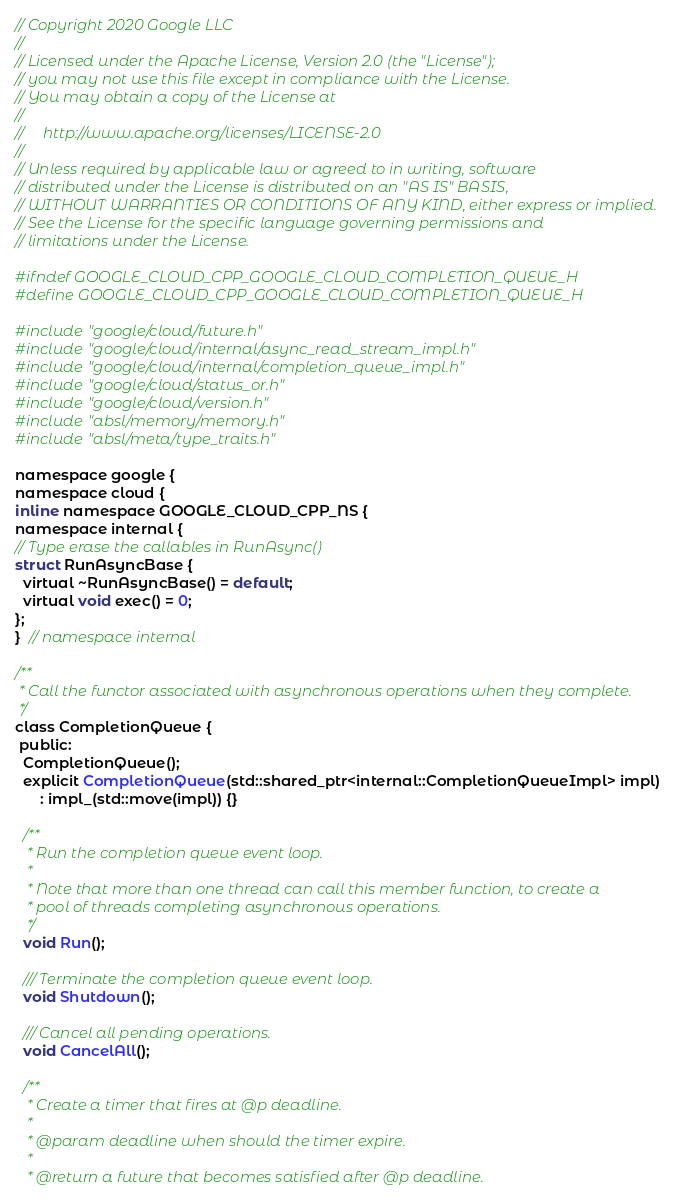Convert code to text. <code><loc_0><loc_0><loc_500><loc_500><_C_>// Copyright 2020 Google LLC
//
// Licensed under the Apache License, Version 2.0 (the "License");
// you may not use this file except in compliance with the License.
// You may obtain a copy of the License at
//
//     http://www.apache.org/licenses/LICENSE-2.0
//
// Unless required by applicable law or agreed to in writing, software
// distributed under the License is distributed on an "AS IS" BASIS,
// WITHOUT WARRANTIES OR CONDITIONS OF ANY KIND, either express or implied.
// See the License for the specific language governing permissions and
// limitations under the License.

#ifndef GOOGLE_CLOUD_CPP_GOOGLE_CLOUD_COMPLETION_QUEUE_H
#define GOOGLE_CLOUD_CPP_GOOGLE_CLOUD_COMPLETION_QUEUE_H

#include "google/cloud/future.h"
#include "google/cloud/internal/async_read_stream_impl.h"
#include "google/cloud/internal/completion_queue_impl.h"
#include "google/cloud/status_or.h"
#include "google/cloud/version.h"
#include "absl/memory/memory.h"
#include "absl/meta/type_traits.h"

namespace google {
namespace cloud {
inline namespace GOOGLE_CLOUD_CPP_NS {
namespace internal {
// Type erase the callables in RunAsync()
struct RunAsyncBase {
  virtual ~RunAsyncBase() = default;
  virtual void exec() = 0;
};
}  // namespace internal

/**
 * Call the functor associated with asynchronous operations when they complete.
 */
class CompletionQueue {
 public:
  CompletionQueue();
  explicit CompletionQueue(std::shared_ptr<internal::CompletionQueueImpl> impl)
      : impl_(std::move(impl)) {}

  /**
   * Run the completion queue event loop.
   *
   * Note that more than one thread can call this member function, to create a
   * pool of threads completing asynchronous operations.
   */
  void Run();

  /// Terminate the completion queue event loop.
  void Shutdown();

  /// Cancel all pending operations.
  void CancelAll();

  /**
   * Create a timer that fires at @p deadline.
   *
   * @param deadline when should the timer expire.
   *
   * @return a future that becomes satisfied after @p deadline.</code> 